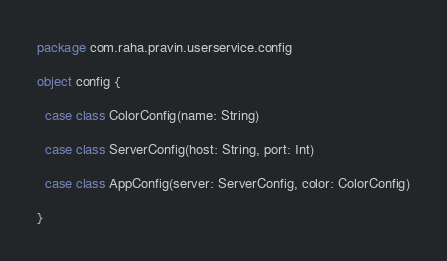<code> <loc_0><loc_0><loc_500><loc_500><_Scala_>package com.raha.pravin.userservice.config

object config {

  case class ColorConfig(name: String)

  case class ServerConfig(host: String, port: Int)

  case class AppConfig(server: ServerConfig, color: ColorConfig)

}
</code> 